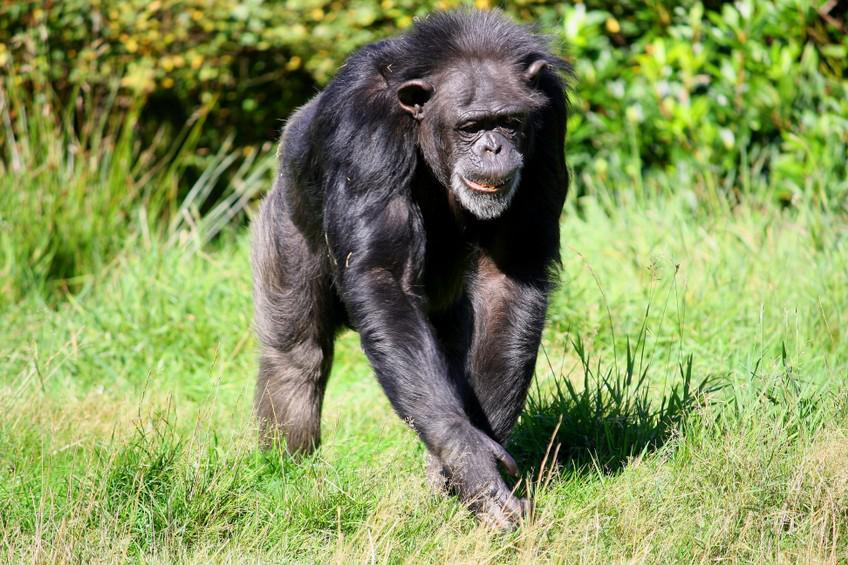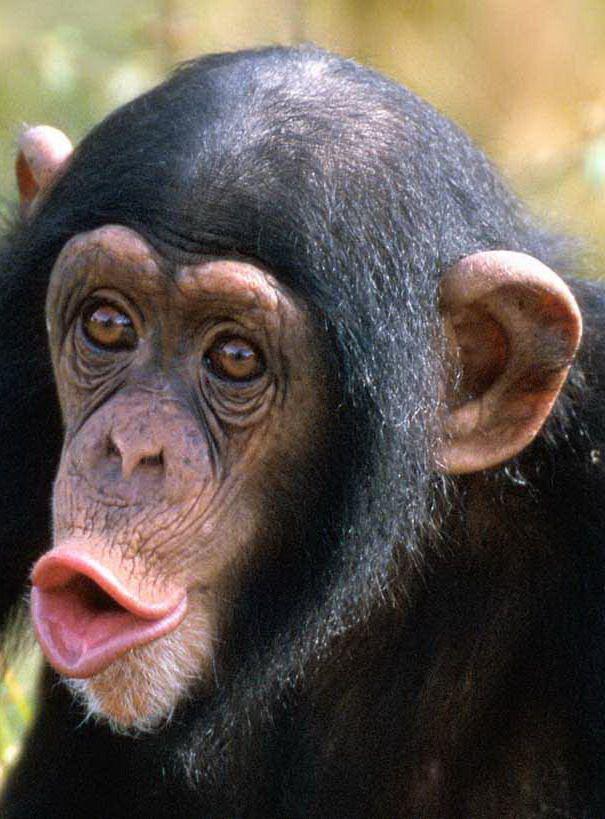The first image is the image on the left, the second image is the image on the right. Evaluate the accuracy of this statement regarding the images: "In one image there is a lone monkey with an open mouth like it is howling.". Is it true? Answer yes or no. Yes. The first image is the image on the left, the second image is the image on the right. For the images shown, is this caption "in the right image a chimp is making an O with it's mouth" true? Answer yes or no. Yes. 